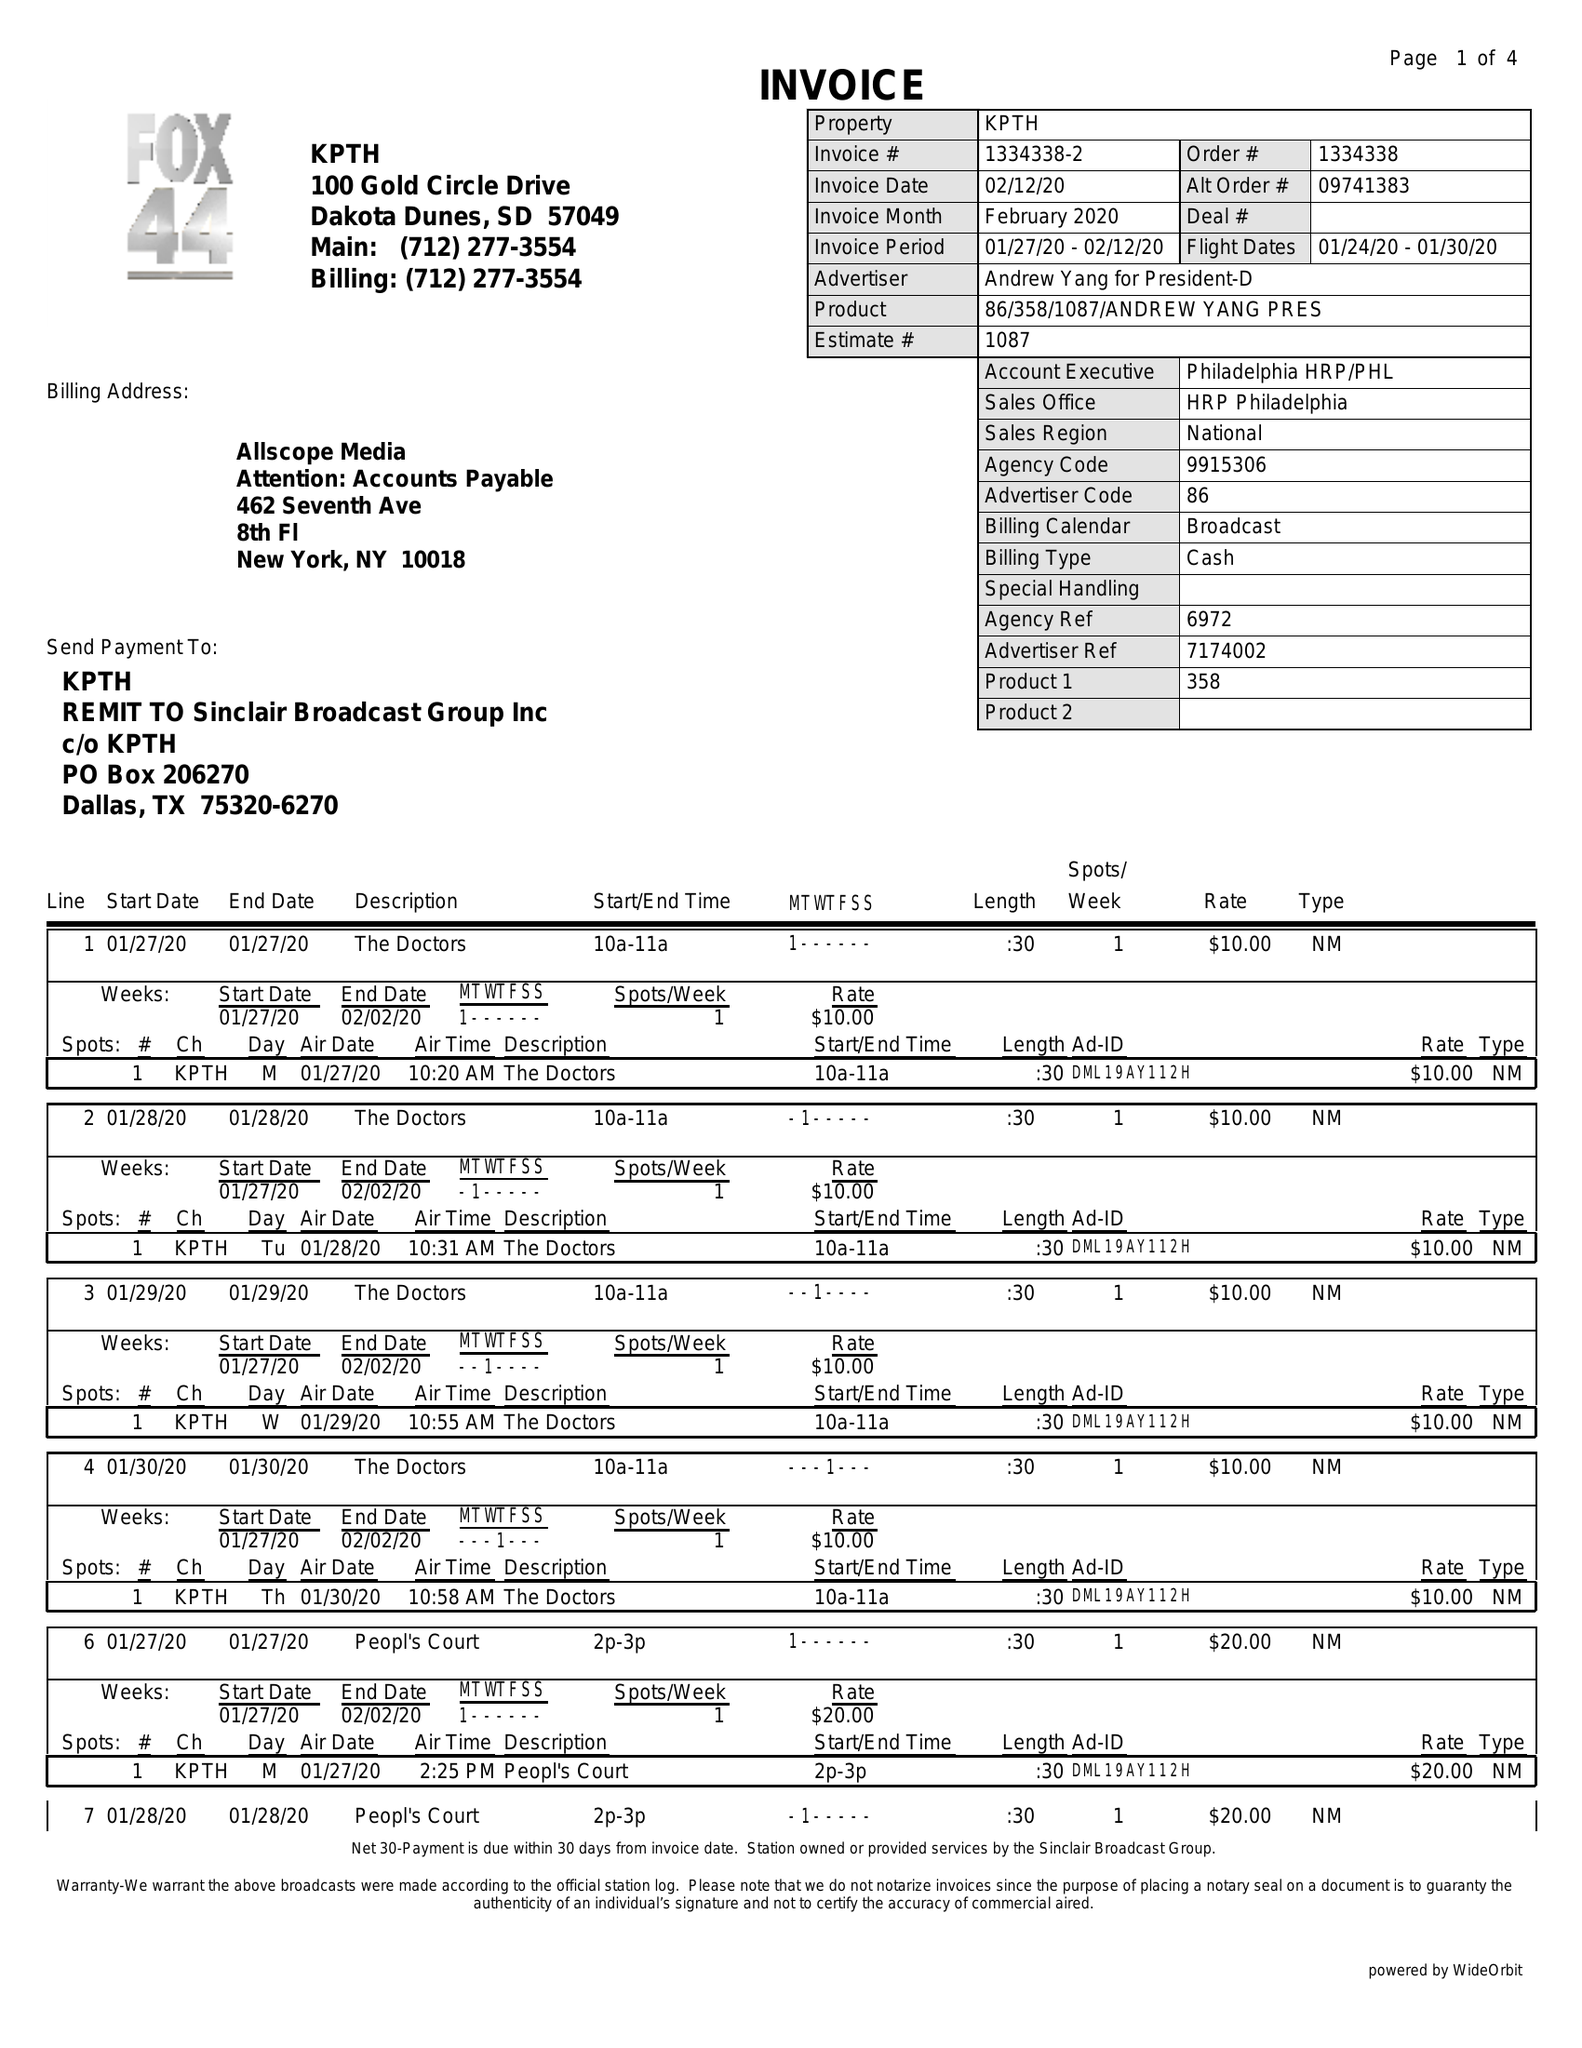What is the value for the advertiser?
Answer the question using a single word or phrase. ANDREW YANG FOR PRESIDENT-D 